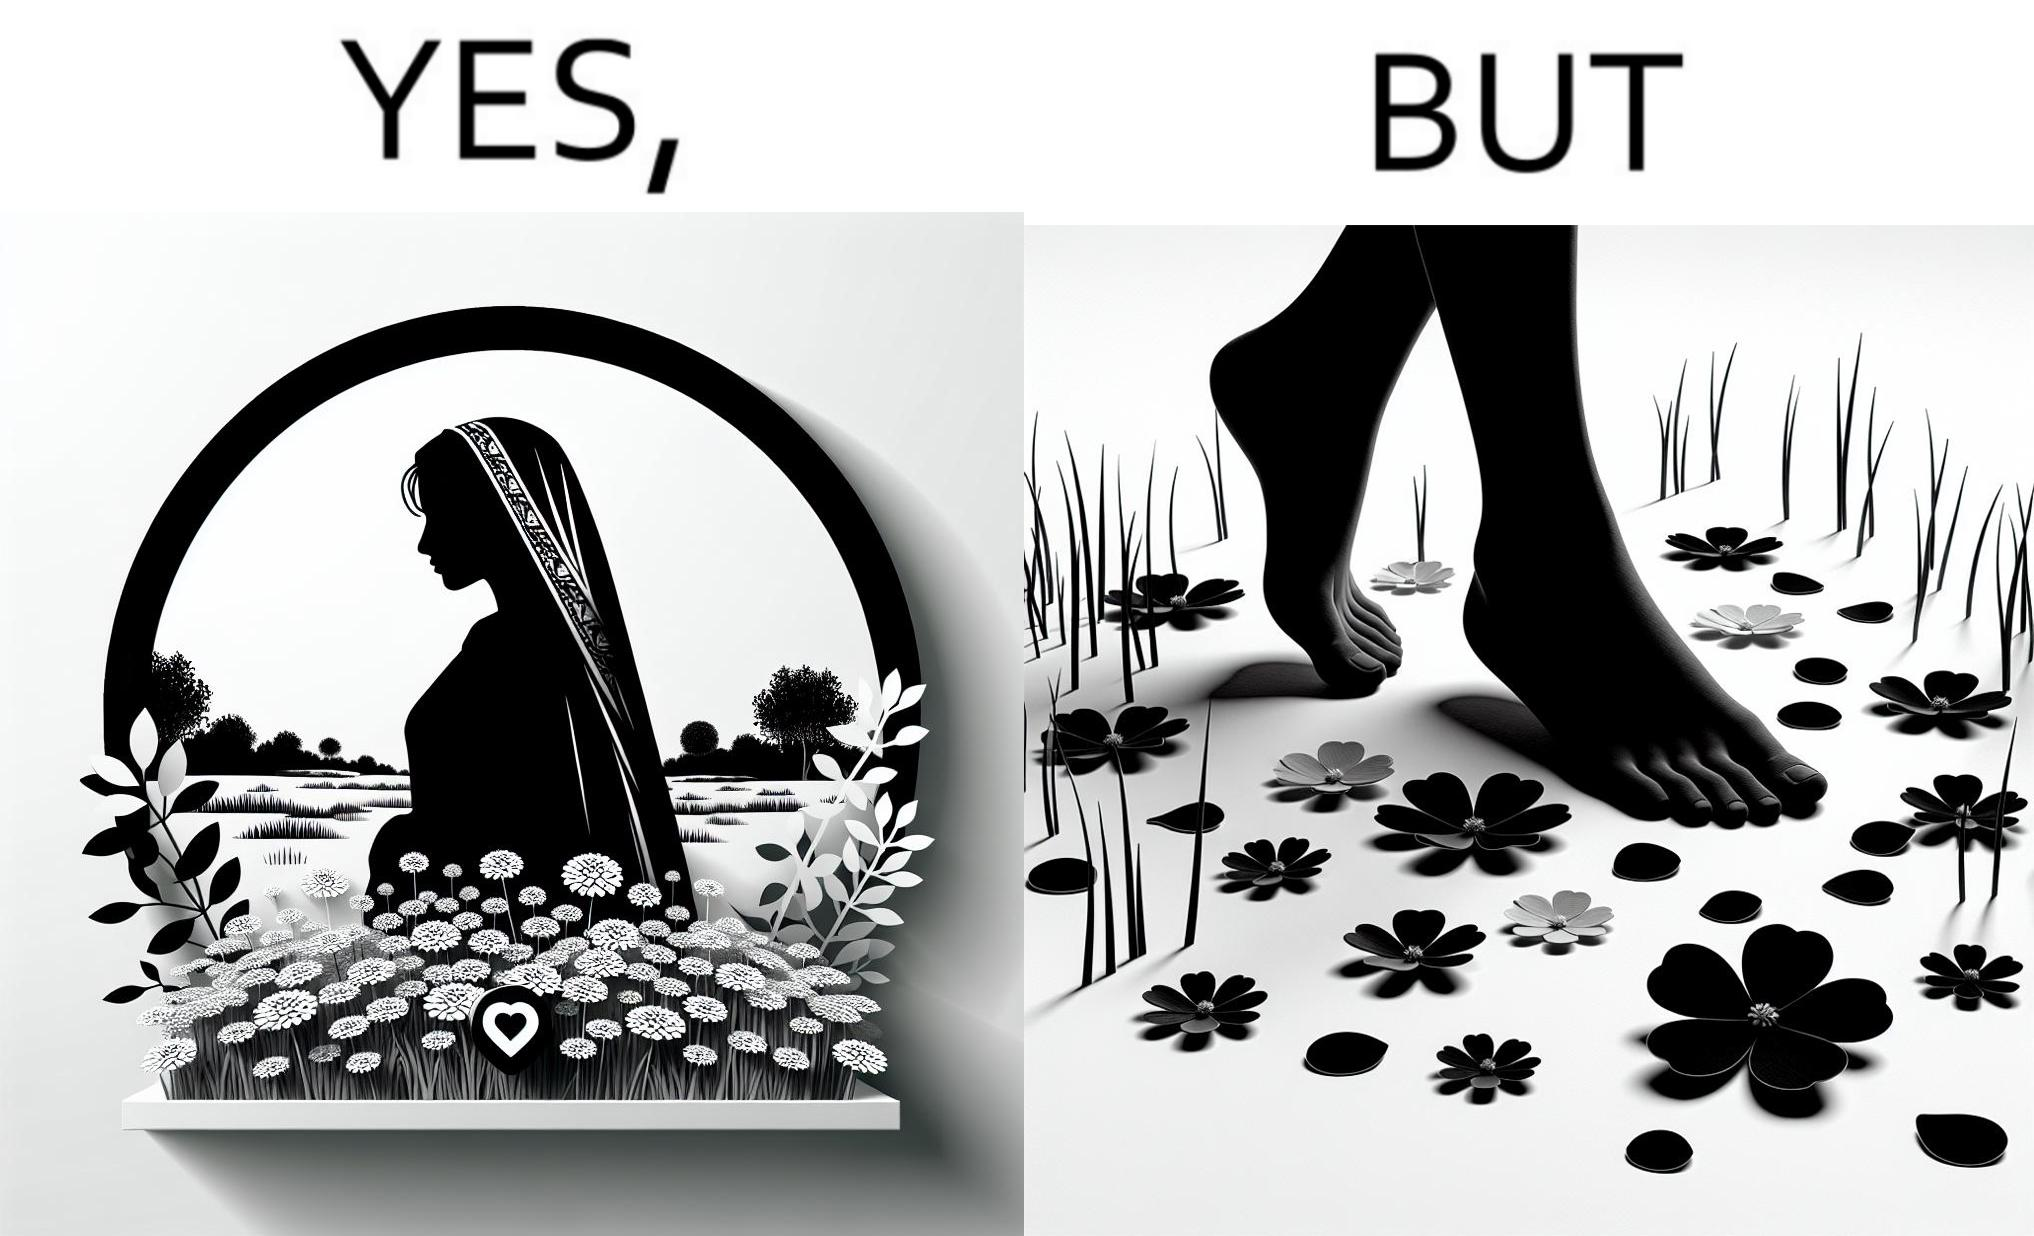What makes this image funny or satirical? The image is ironical, as the social ,edia post shows the appreciation of nature, while an image of the feet on the ground stepping on the flower petals shows an unintentional disrespect of nature. 